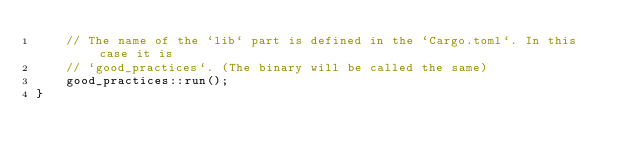Convert code to text. <code><loc_0><loc_0><loc_500><loc_500><_Rust_>    // The name of the `lib` part is defined in the `Cargo.toml`. In this case it is
    // `good_practices`. (The binary will be called the same)
    good_practices::run();
}
</code> 